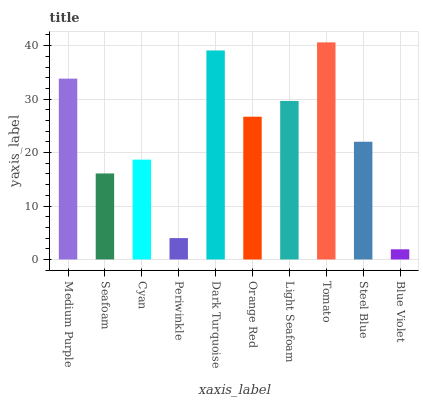Is Blue Violet the minimum?
Answer yes or no. Yes. Is Tomato the maximum?
Answer yes or no. Yes. Is Seafoam the minimum?
Answer yes or no. No. Is Seafoam the maximum?
Answer yes or no. No. Is Medium Purple greater than Seafoam?
Answer yes or no. Yes. Is Seafoam less than Medium Purple?
Answer yes or no. Yes. Is Seafoam greater than Medium Purple?
Answer yes or no. No. Is Medium Purple less than Seafoam?
Answer yes or no. No. Is Orange Red the high median?
Answer yes or no. Yes. Is Steel Blue the low median?
Answer yes or no. Yes. Is Seafoam the high median?
Answer yes or no. No. Is Tomato the low median?
Answer yes or no. No. 